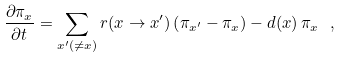Convert formula to latex. <formula><loc_0><loc_0><loc_500><loc_500>\frac { \partial \pi _ { x } } { \partial t } = \sum _ { x ^ { \prime } ( \ne x ) } r ( x \to x ^ { \prime } ) \left ( \pi _ { x ^ { \prime } } - \pi _ { x } \right ) - d ( x ) \, \pi _ { x } \ ,</formula> 